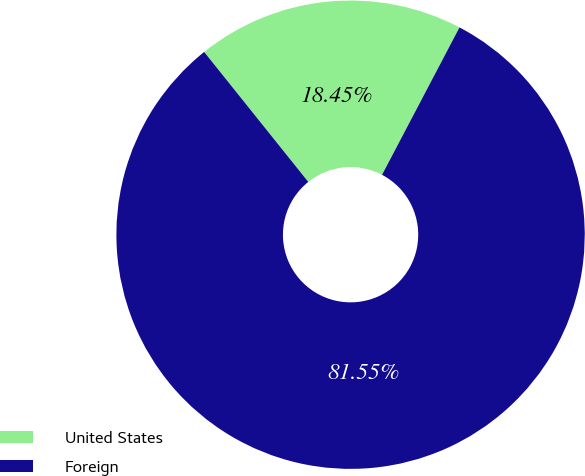Convert chart to OTSL. <chart><loc_0><loc_0><loc_500><loc_500><pie_chart><fcel>United States<fcel>Foreign<nl><fcel>18.45%<fcel>81.55%<nl></chart> 